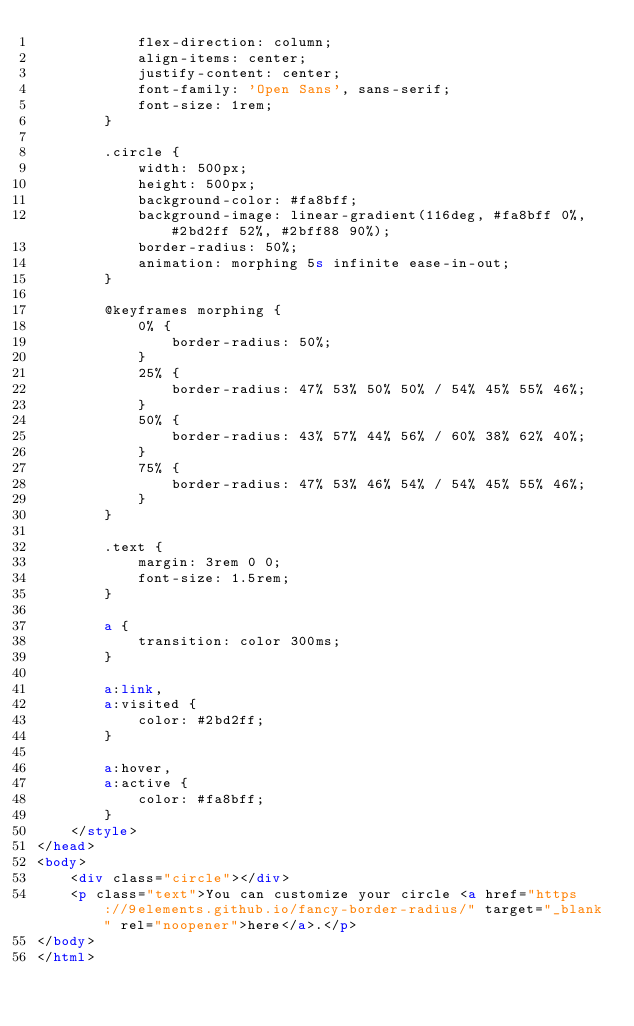Convert code to text. <code><loc_0><loc_0><loc_500><loc_500><_HTML_>			flex-direction: column;
			align-items: center;
			justify-content: center;
			font-family: 'Open Sans', sans-serif;
			font-size: 1rem;
		}

		.circle {
			width: 500px;
			height: 500px;
			background-color: #fa8bff;
			background-image: linear-gradient(116deg, #fa8bff 0%, #2bd2ff 52%, #2bff88 90%);
			border-radius: 50%;
			animation: morphing 5s infinite ease-in-out;
		}

		@keyframes morphing {
			0% {
				border-radius: 50%;
			}
			25% {
				border-radius: 47% 53% 50% 50% / 54% 45% 55% 46%;
			}
			50% {
				border-radius: 43% 57% 44% 56% / 60% 38% 62% 40%;
			}
			75% {
				border-radius: 47% 53% 46% 54% / 54% 45% 55% 46%;
			}
		}

		.text {
			margin: 3rem 0 0;
			font-size: 1.5rem;
		}

		a {
			transition: color 300ms;
		}

		a:link,
		a:visited {
			color: #2bd2ff;
		}

		a:hover,
		a:active {
			color: #fa8bff;
		}
	</style>
</head>
<body>
	<div class="circle"></div>
	<p class="text">You can customize your circle <a href="https://9elements.github.io/fancy-border-radius/" target="_blank" rel="noopener">here</a>.</p>
</body>
</html>
</code> 